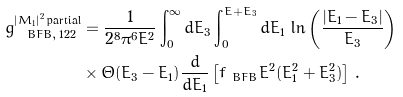Convert formula to latex. <formula><loc_0><loc_0><loc_500><loc_500>g _ { \ B F B , \, 1 2 2 } ^ { | M _ { 1 } | ^ { 2 } \, \text {partial} } & = \frac { 1 } { 2 ^ { 8 } \pi ^ { 6 } E ^ { 2 } } \int _ { 0 } ^ { \infty } d E _ { 3 } \int _ { 0 } ^ { E + E _ { 3 } } d E _ { 1 } \, \ln \left ( \frac { | E _ { 1 } - E _ { 3 } | } { E _ { 3 } } \right ) \\ & \times \Theta ( E _ { 3 } - E _ { 1 } ) \frac { d } { d E _ { 1 } } \left [ f _ { \ B F B } E ^ { 2 } ( E _ { 1 } ^ { 2 } + E _ { 3 } ^ { 2 } ) \right ] \, .</formula> 